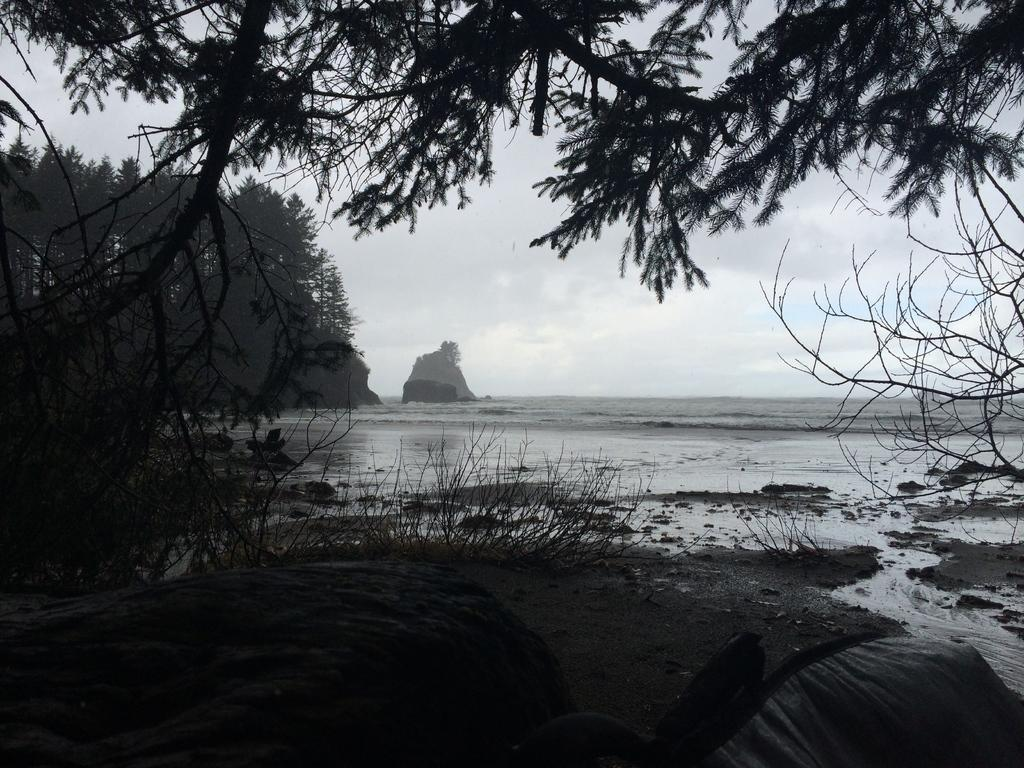What natural feature can be seen in the sky in the image? There is no specific natural feature visible in the sky in the image. What type of landform is present in the image? There is a mountain in the image. What body of water is visible in the image? There is sea in the image. What type of vegetation can be seen in the image? There are trees and plants in the image. What type of poison is being used by the cats in the image? There are no cats or poison present in the image. What mark can be seen on the mountain in the image? There is no mark visible on the mountain in the image. 